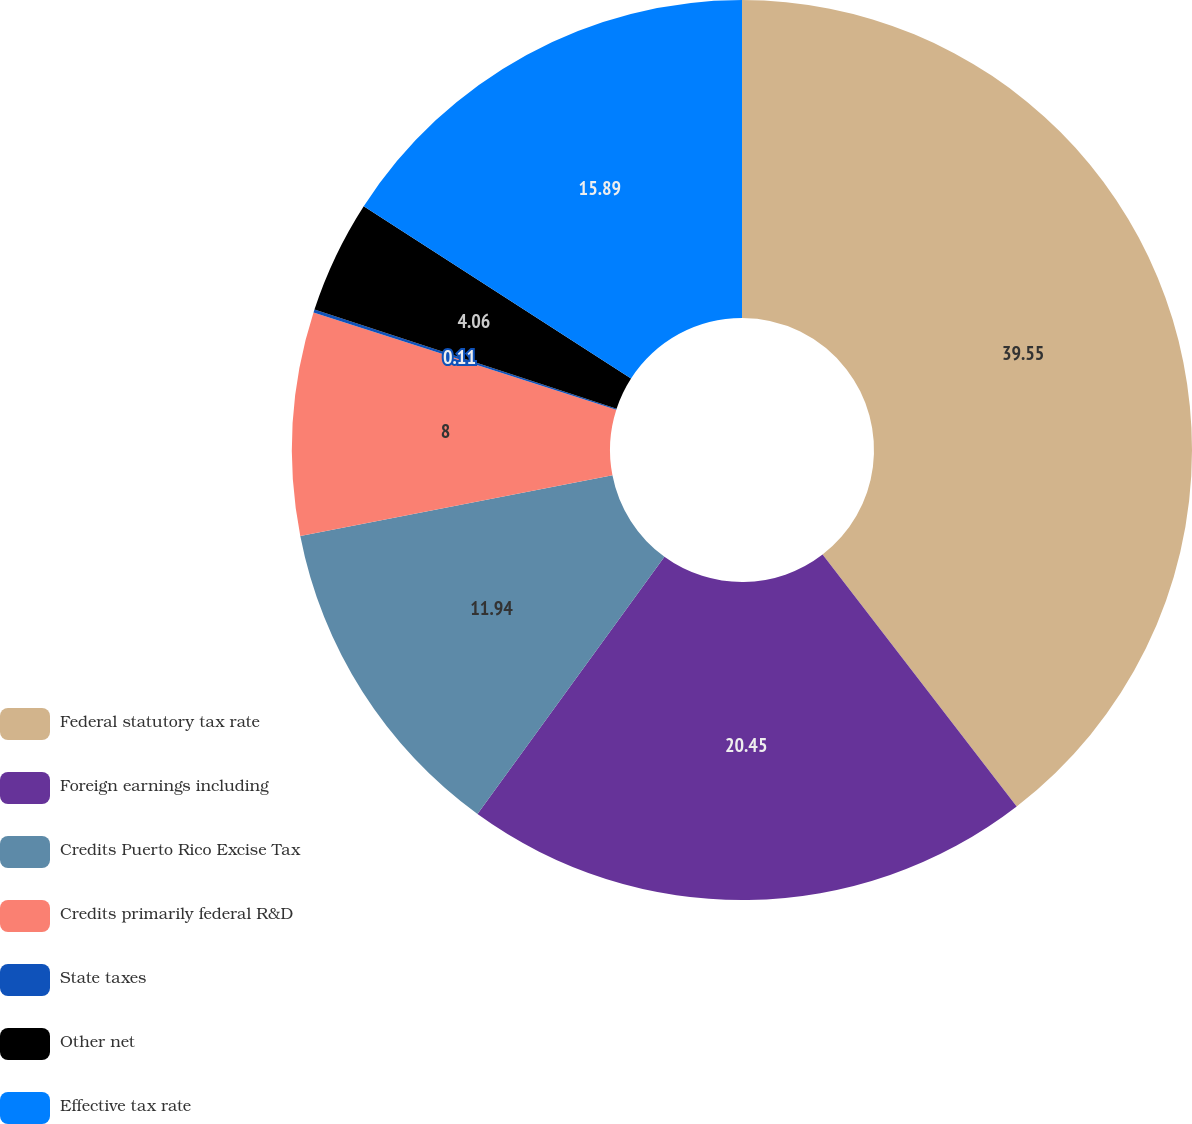Convert chart. <chart><loc_0><loc_0><loc_500><loc_500><pie_chart><fcel>Federal statutory tax rate<fcel>Foreign earnings including<fcel>Credits Puerto Rico Excise Tax<fcel>Credits primarily federal R&D<fcel>State taxes<fcel>Other net<fcel>Effective tax rate<nl><fcel>39.55%<fcel>20.45%<fcel>11.94%<fcel>8.0%<fcel>0.11%<fcel>4.06%<fcel>15.89%<nl></chart> 